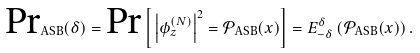<formula> <loc_0><loc_0><loc_500><loc_500>\text {Pr} _ { \text {ASB} } ( \delta ) = \text {Pr} \left [ \, \left | \phi ^ { ( N ) } _ { z } \right | ^ { 2 } = \mathcal { P } _ { \text {ASB} } ( x ) \right ] = E ^ { \delta } _ { - \delta } \left ( \mathcal { P } _ { \text {ASB} } ( x ) \right ) .</formula> 